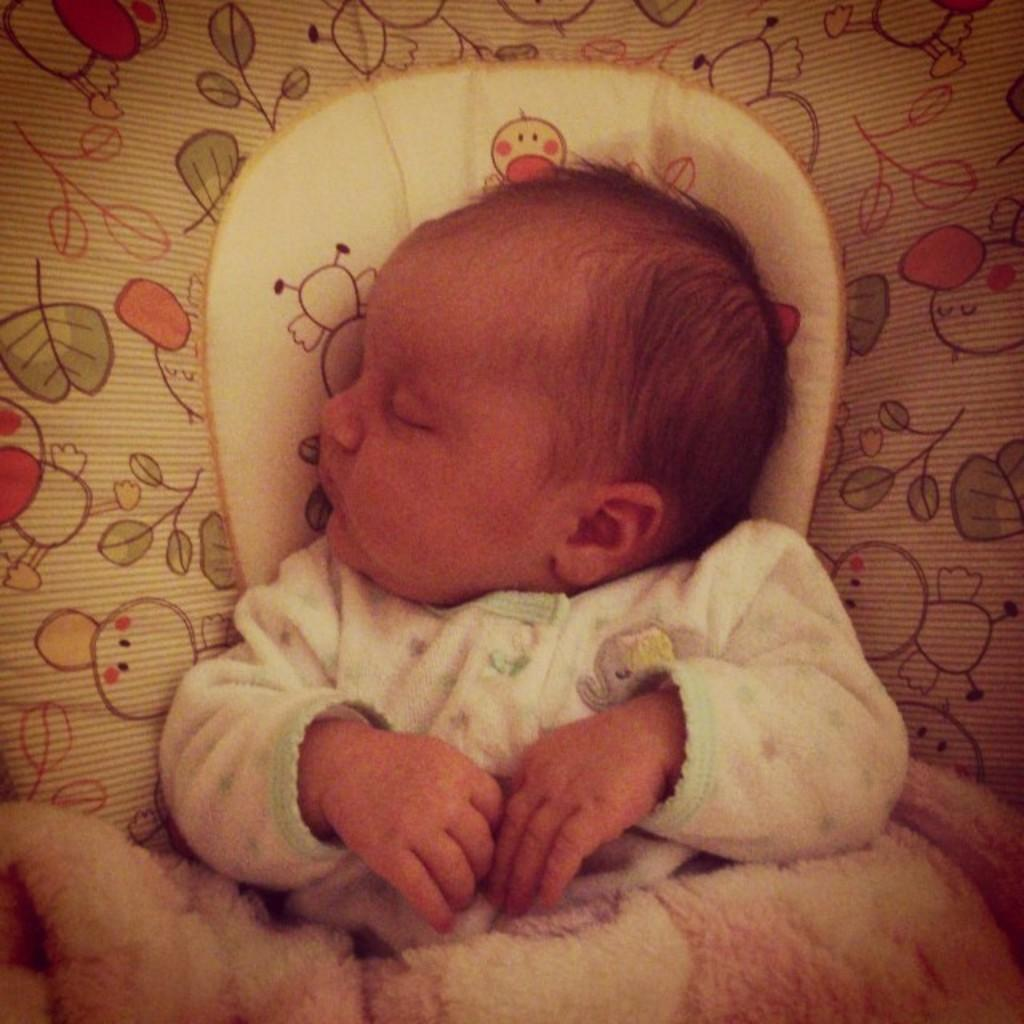What is the main subject of the image? The main subject of the image is a baby. What is the baby wearing in the image? The baby is wearing a white dress in the image. What is the baby doing in the image? The baby is sleeping in the image. Where is the baby located in the image? The baby is on a bed in the image. What is present at the bottom of the picture? There is a blanket at the bottom of the picture. Can you tell me how many parents are visible in the image? There are no parents visible in the image; it only features a baby. What type of sea creature is swimming under the baby's bed in the image? There is no sea creature present in the image, as it is a baby sleeping on a bed with a blanket. 